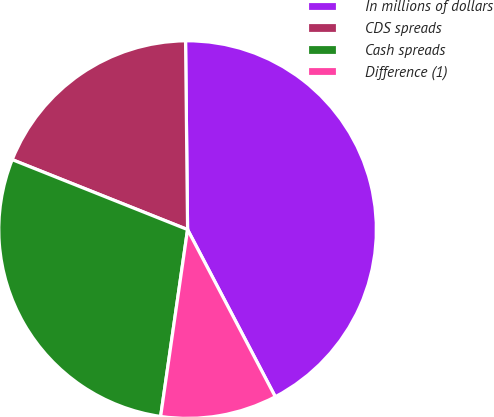<chart> <loc_0><loc_0><loc_500><loc_500><pie_chart><fcel>In millions of dollars<fcel>CDS spreads<fcel>Cash spreads<fcel>Difference (1)<nl><fcel>42.48%<fcel>18.79%<fcel>28.76%<fcel>9.97%<nl></chart> 